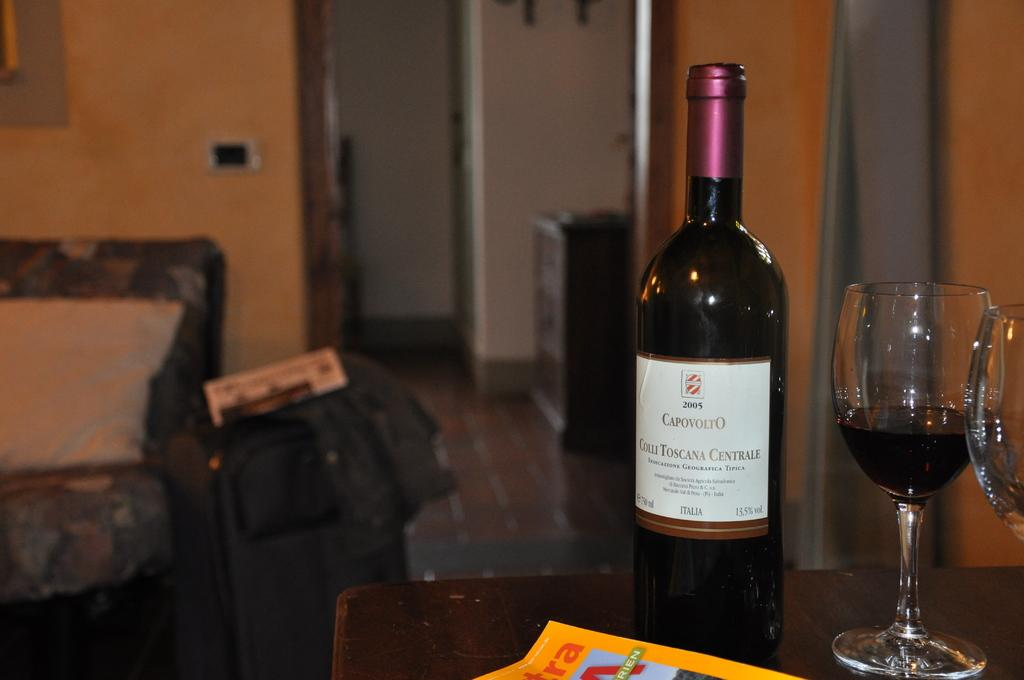<image>
Offer a succinct explanation of the picture presented. 2005 Capovolto is labeled on this wine bottle. 